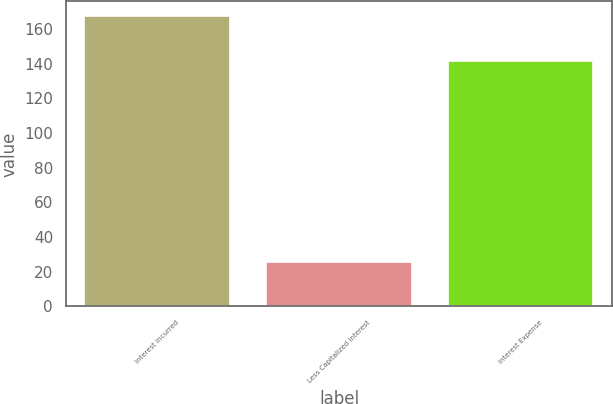<chart> <loc_0><loc_0><loc_500><loc_500><bar_chart><fcel>Interest incurred<fcel>Less Capitalized interest<fcel>Interest Expense<nl><fcel>167.6<fcel>25.8<fcel>141.8<nl></chart> 